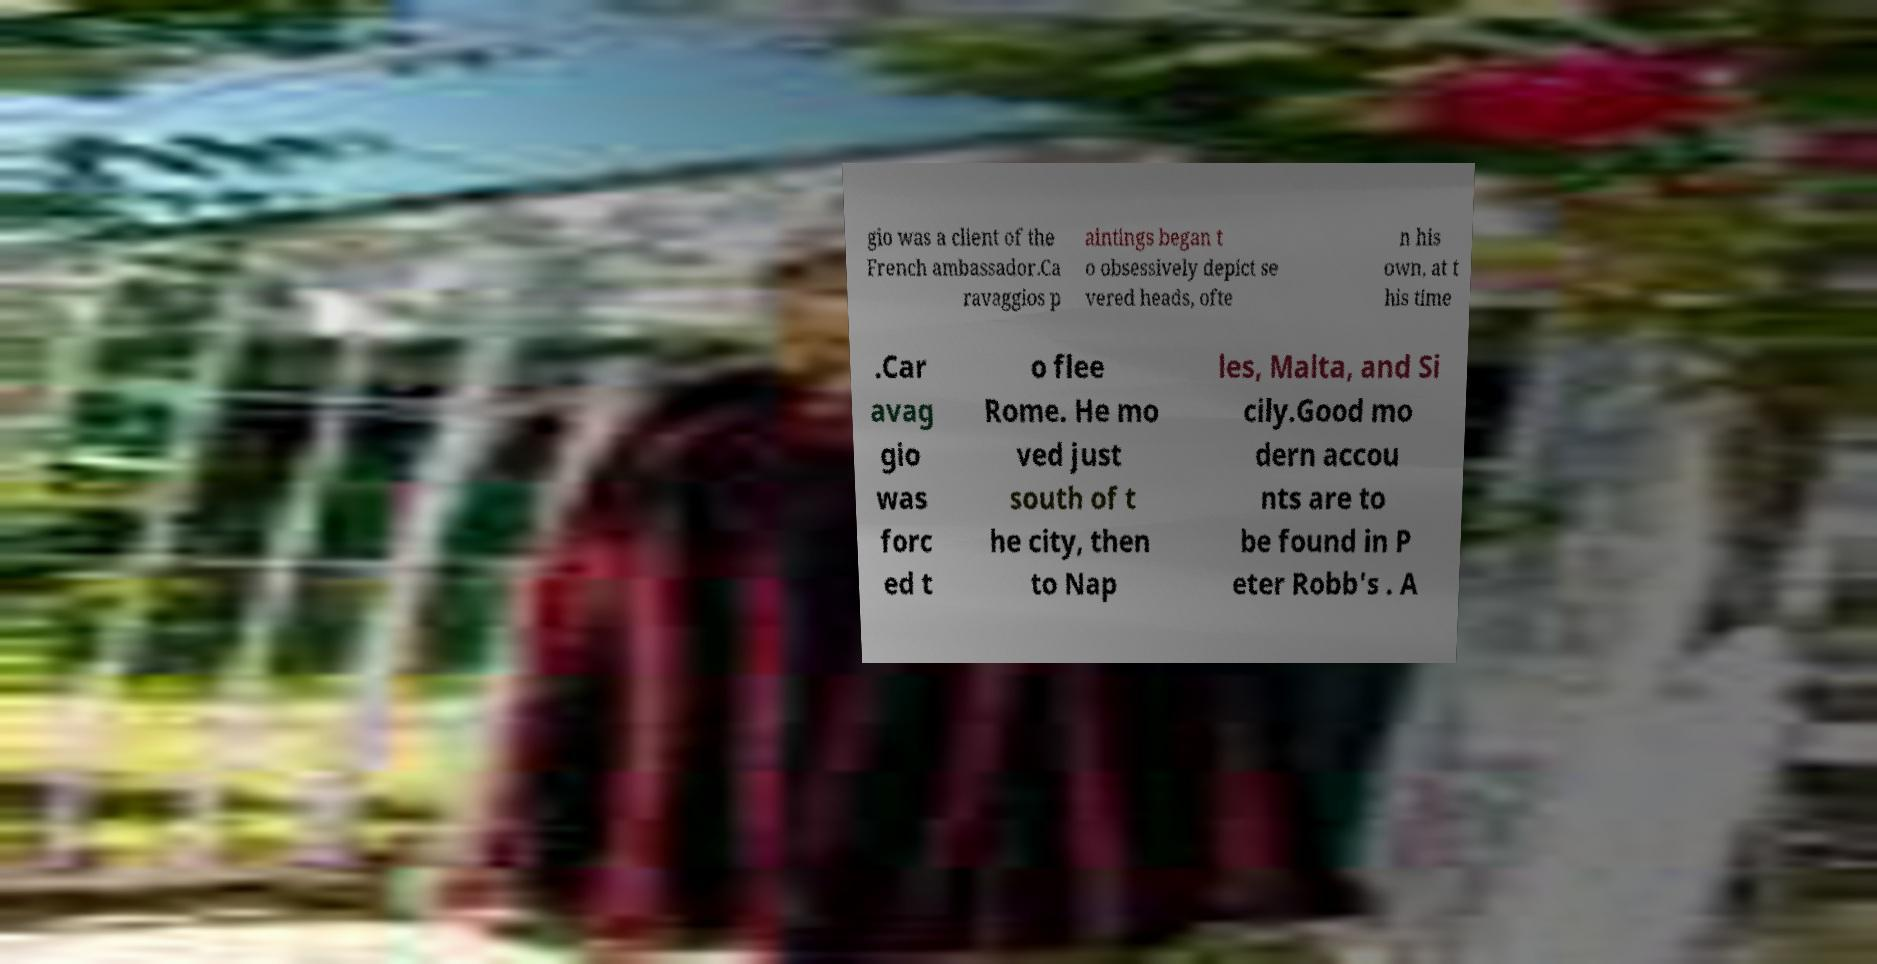I need the written content from this picture converted into text. Can you do that? gio was a client of the French ambassador.Ca ravaggios p aintings began t o obsessively depict se vered heads, ofte n his own, at t his time .Car avag gio was forc ed t o flee Rome. He mo ved just south of t he city, then to Nap les, Malta, and Si cily.Good mo dern accou nts are to be found in P eter Robb's . A 